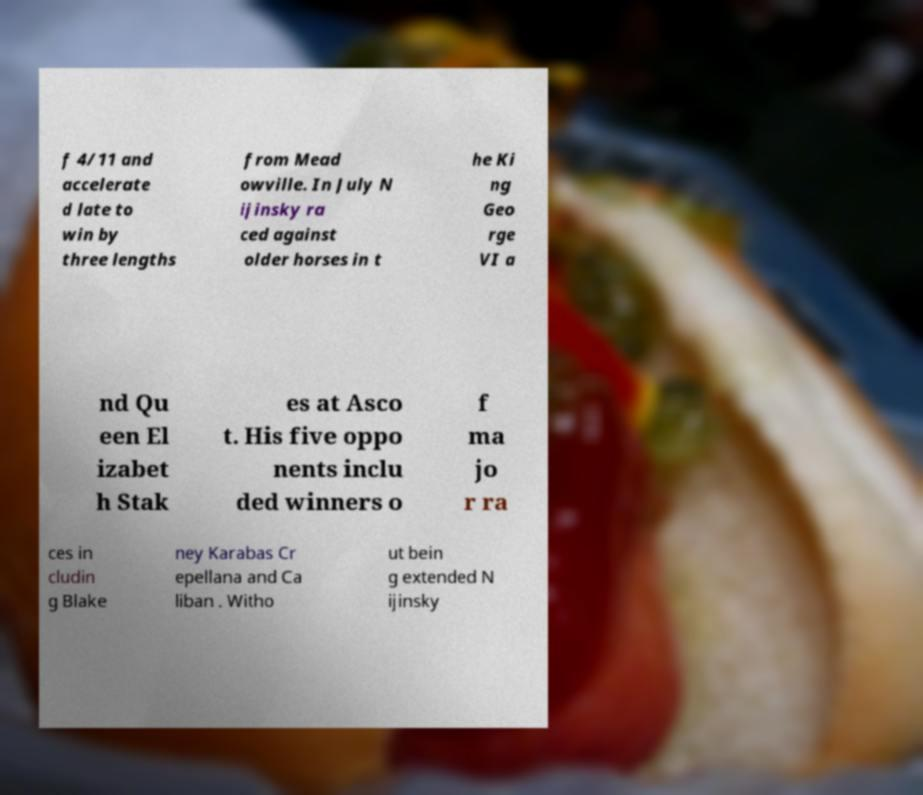I need the written content from this picture converted into text. Can you do that? f 4/11 and accelerate d late to win by three lengths from Mead owville. In July N ijinsky ra ced against older horses in t he Ki ng Geo rge VI a nd Qu een El izabet h Stak es at Asco t. His five oppo nents inclu ded winners o f ma jo r ra ces in cludin g Blake ney Karabas Cr epellana and Ca liban . Witho ut bein g extended N ijinsky 